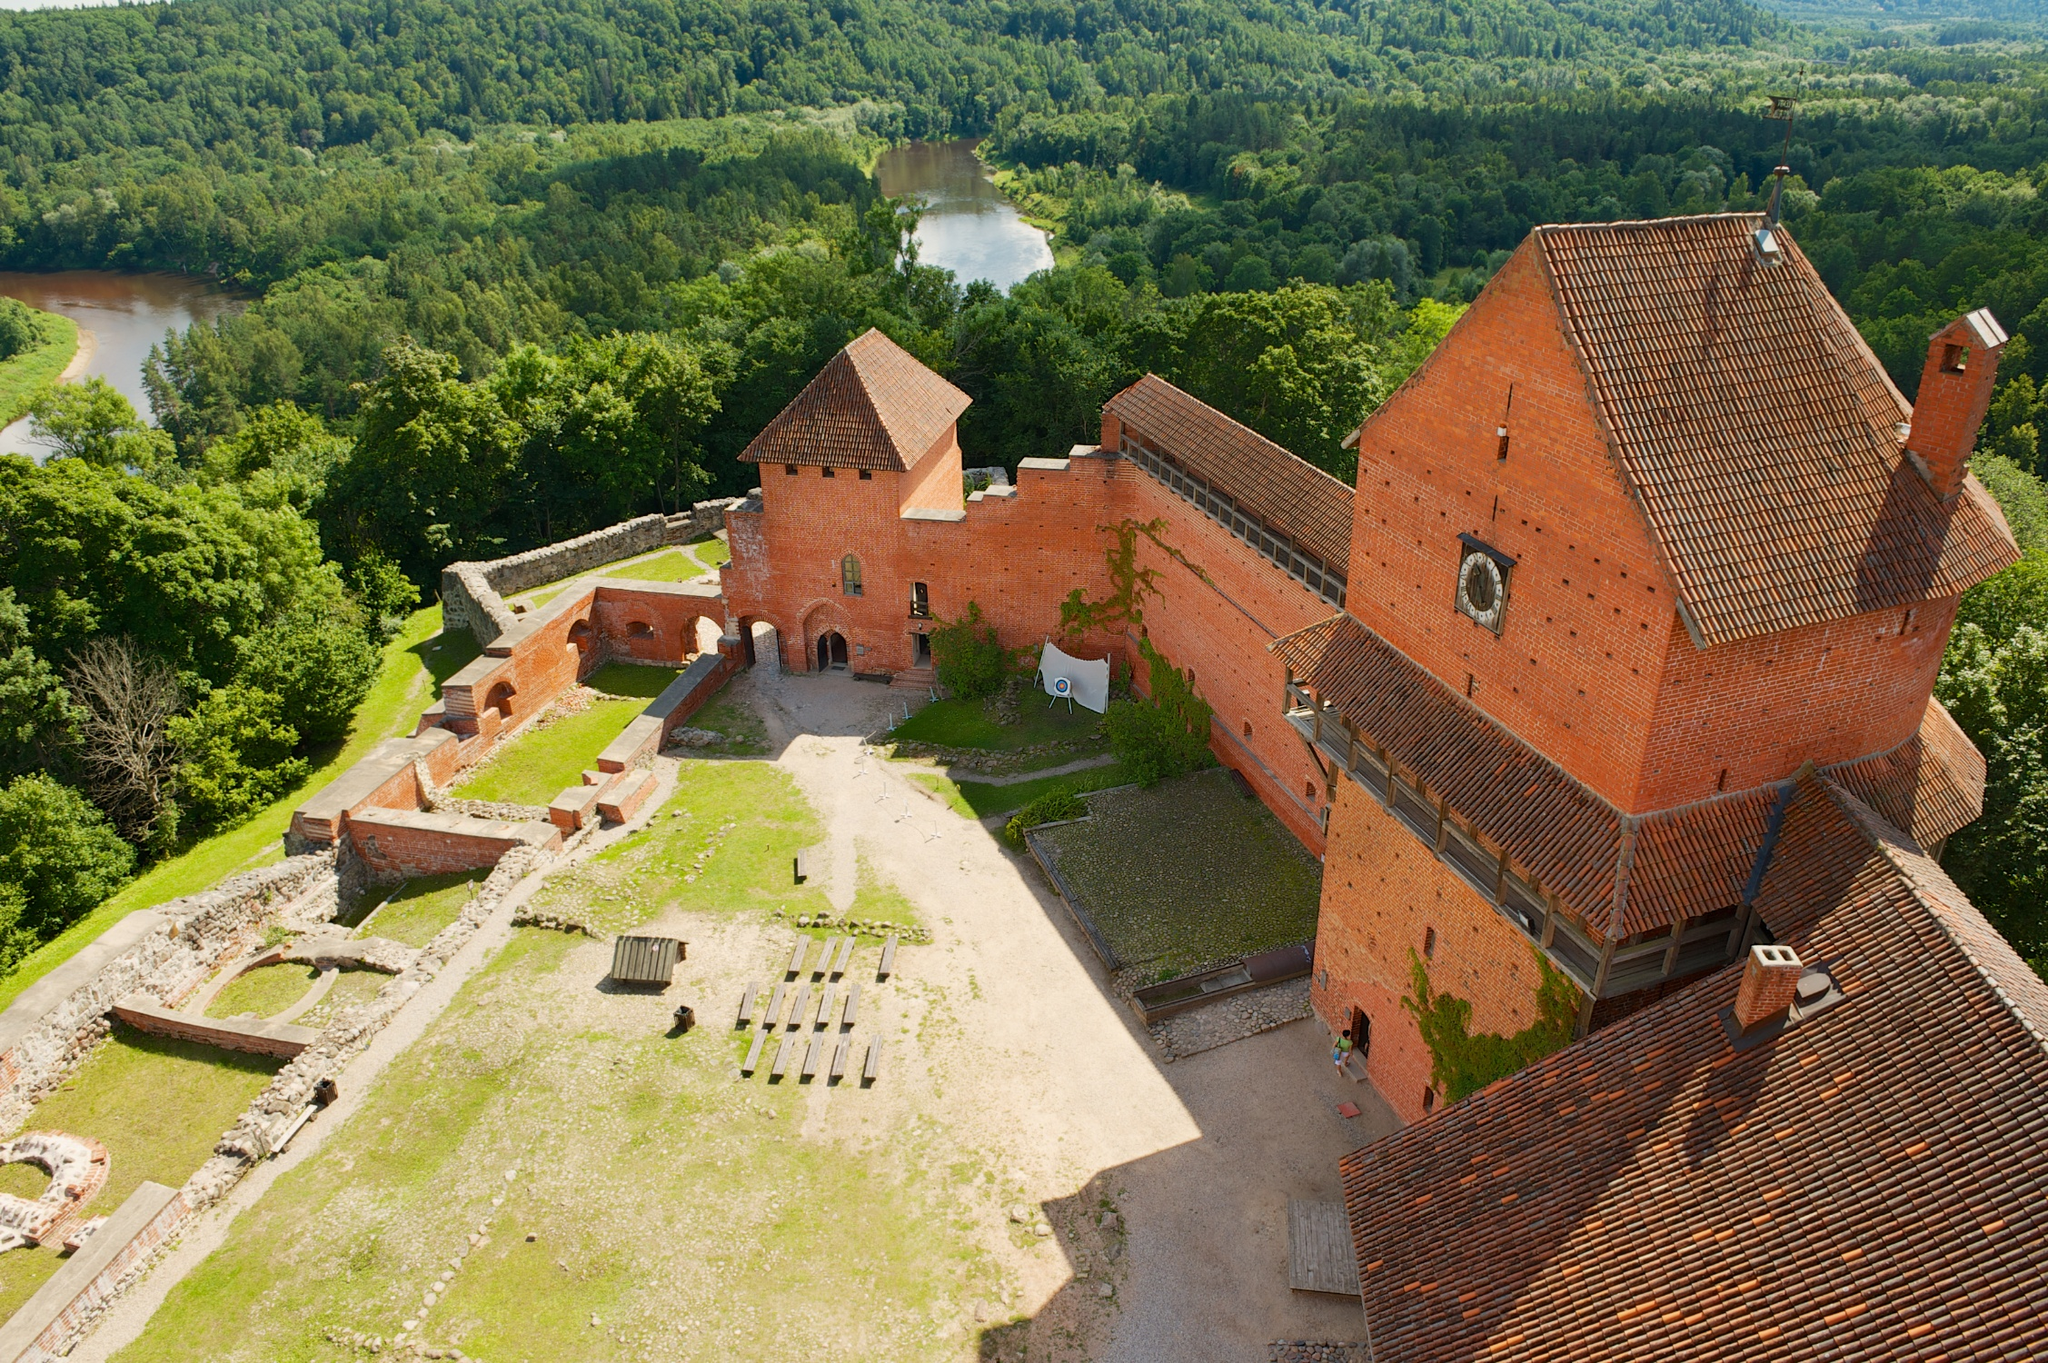Who was the most famous person associated with this castle, and what were they known for? The most famous person associated with this castle was Sir Alden the Brave, a legendary knight known for his unparalleled courage and strategic brilliance. Sir Alden's most renowned feat was defending the castle and its surrounding lands from a formidable invasion. Leading a smaller, poorly equipped force, he devised ingenious defensive tactics that turned the tides of battle. His leadership not only ensured the survival of the castle but also solidified his place in history as a paragon of knightly virtue. 